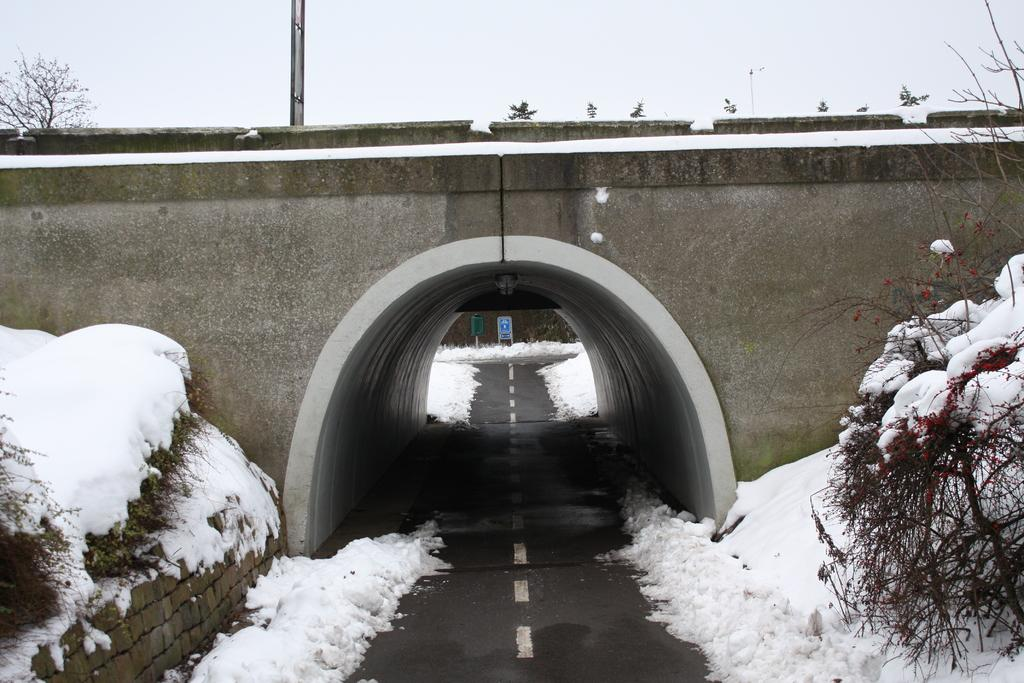What type of pathway can be seen in the image? There is a road in the image. What structure is present over the road? There is a bridge in the image. What is covering the ground on both sides of the road? Snow is present on both sides of the road. What type of vegetation is visible on both sides of the road? Plants are visible on both sides of the road. What can be seen in the background of the image? There are boards, a pole, trees, and the sky visible in the background of the image. How many dogs are visible on the bridge in the image? There are no dogs present in the image. What type of tongue can be seen sticking out from the pole in the background? There is no tongue present in the image; the pole is an inanimate object. 